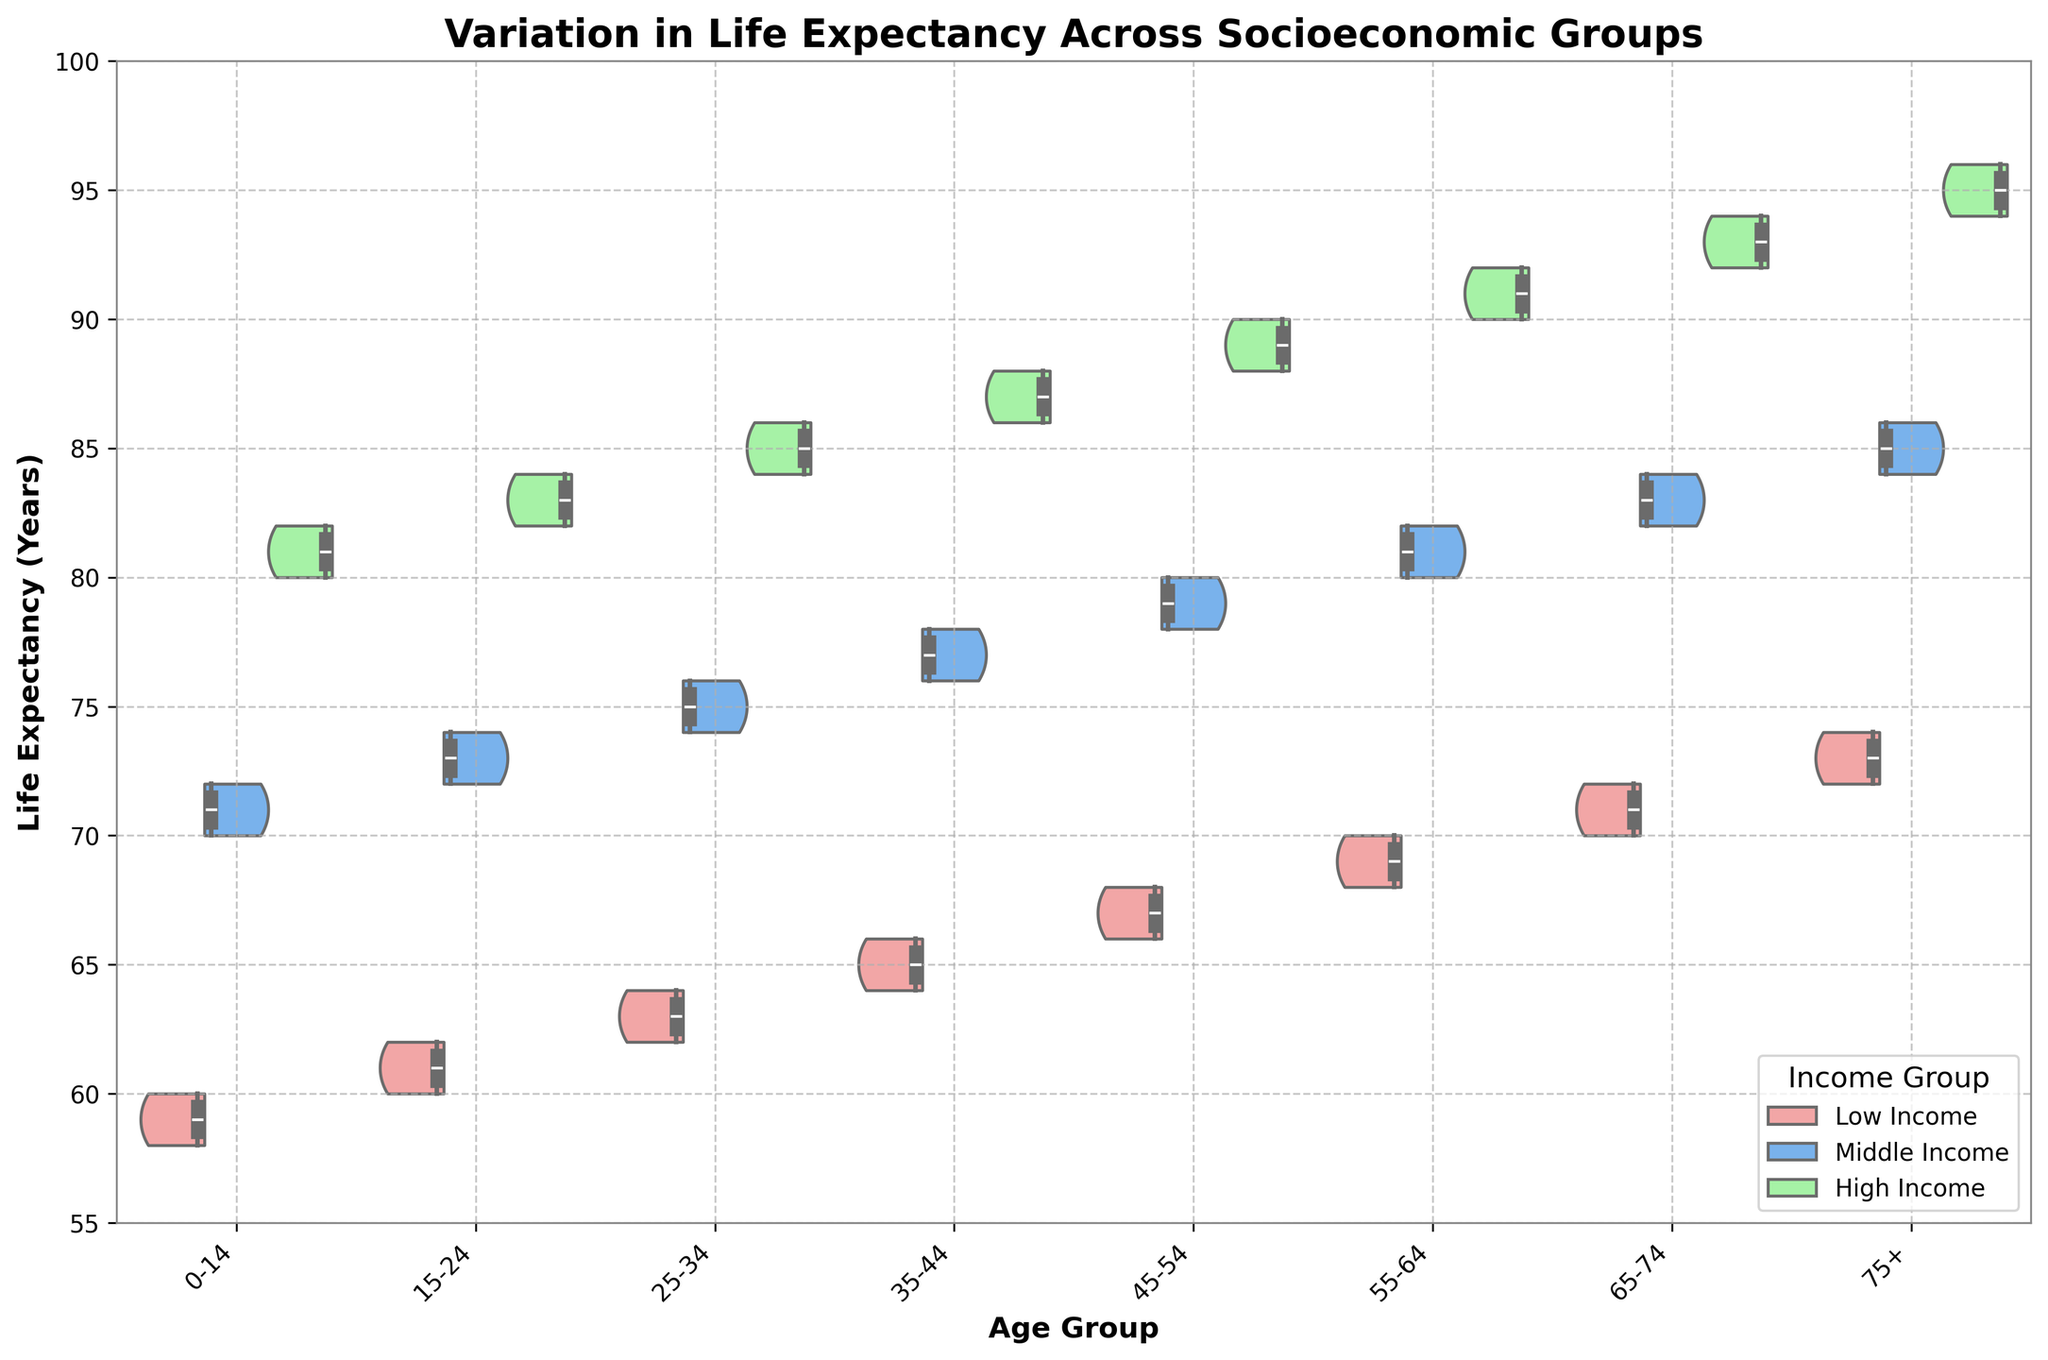What is the title of the plot? The title is positioned at the top of the plot in a larger and bold font. It reads "Variation in Life Expectancy Across Socioeconomic Groups."
Answer: Variation in Life Expectancy Across Socioeconomic Groups What are the x-axis and y-axis labels? The x-axis label, located below the horizontal axis, is "Age Group," and the y-axis label, situated beside the vertical axis, is "Life Expectancy (Years)."
Answer: Age Group; Life Expectancy (Years) How many different socioeconomic groups are represented in the plot? The legend on the plot indicates three different socioeconomic groups: Low Income, Middle Income, and High Income.
Answer: 3 Which age group shows the highest life expectancy for high-income individuals? By observing the green violin plot for high income, the age group 75+ shows the highest life expectancy.
Answer: 75+ What is the range of life expectancy for low-income individuals in the 15-24 age group? The life expectancy range for low-income individuals in the 15-24 age group is shown by the spread of the red violin plot and the inner box plot. It ranges from approximately 60 to 62 years.
Answer: 60-62 years Which income group has the widest spread in life expectancy for the 35-44 age group? By examining the whiskers and spread of the violin plots, the high-income group (green) has the widest spread in life expectancy for the 35-44 age group, ranging from 86 to 88 years.
Answer: High Income Compare the median life expectancy of middle-income individuals between the 25-34 and 55-64 age groups. The median is represented by the line within the box plot inside the violin plot. For middle-income individuals:
- 25-34 age group: Median appears around 75 years.
- 55-64 age group: Median appears around 81 years.
Thus, the 55-64 age group has a higher median life expectancy.
Answer: 55-64 age group has a higher median Which age group has the smallest difference in life expectancy between high-income and middle-income groups? By examining the overlay of the violin plots and their respective box plots, the 75+ age group shows the smallest difference between high-income and middle-income groups, with life expectancies of 94-96 years for high income and 84-86 years for middle income.
Answer: 75+ For which age group is the overlap between low-income and middle-income groups the most extensive? By visually inspecting the overlap of the red and blue violin plots, the 0-14 age group shows the most extensive overlap between low-income and middle-income groups, with life expectancies of 58-60 years and 70-72 years, respectively.
Answer: 0-14 What is the visual pattern observed in life expectancy across age groups for high-income individuals? The green violin plots for high-income individuals show an increasing trend in life expectancy as age groups advance, starting from around 80 years in the 0-14 group to about 94-96 years in the 75+ group.
Answer: Increasing trend 